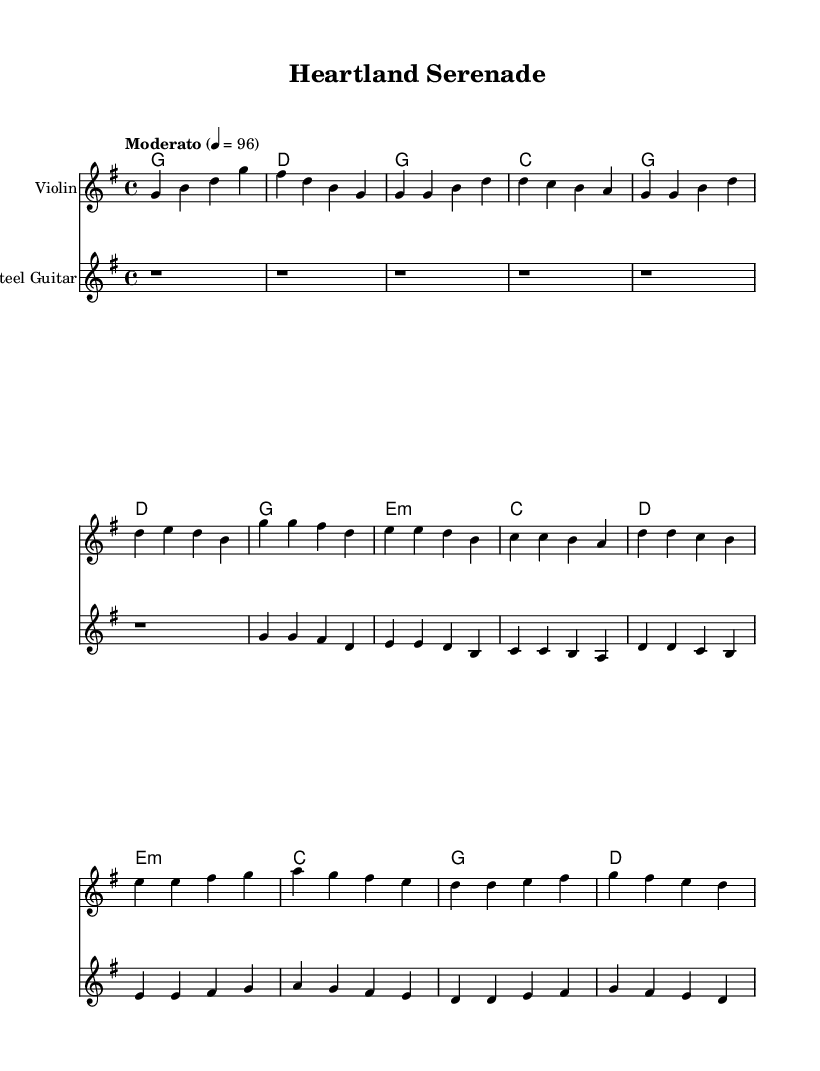What is the key signature of this music? The key signature is G major, which has one sharp (F sharp). This can be determined by looking at the key signature indicated at the beginning of the piece.
Answer: G major What is the time signature of this music? The time signature is 4/4, which shows that there are four beats in each measure and a quarter note receives one beat. This information is reflected in the notation at the beginning of the score.
Answer: 4/4 What is the tempo marking for this piece? The tempo marking is "Moderato," indicated in the header with the metronome marking of 96 beats per minute, which describes a moderate pace for the performance.
Answer: Moderato How many measures are there in the chorus section? The chorus section consists of four measures, which can be counted from the notation where the chorus starts and ends. This segment is distinct from the verse and bridge sections.
Answer: Four In which section does the steel guitar start playing notes? The steel guitar begins playing notes in the chorus section after the intro, indicated by the start of melodic lines rather than rests. This transition shows the collaboration between instruments in this part of the composition.
Answer: Chorus Which chord is played in the bridge section? The chords played in the bridge section include E minor, C, G, and D. This can be seen in the chord mode part of the score where the harmonies for each section are specified, with the bridge presenting this specific progression.
Answer: E minor What instrument is indicated as "Violin" in this score? The instrument indicated as "Violin" is the first staff, which contains the specific notes and melody line for the violin throughout the piece, thus clearly showing its role in this contemporary country-classical fusion.
Answer: Violin 